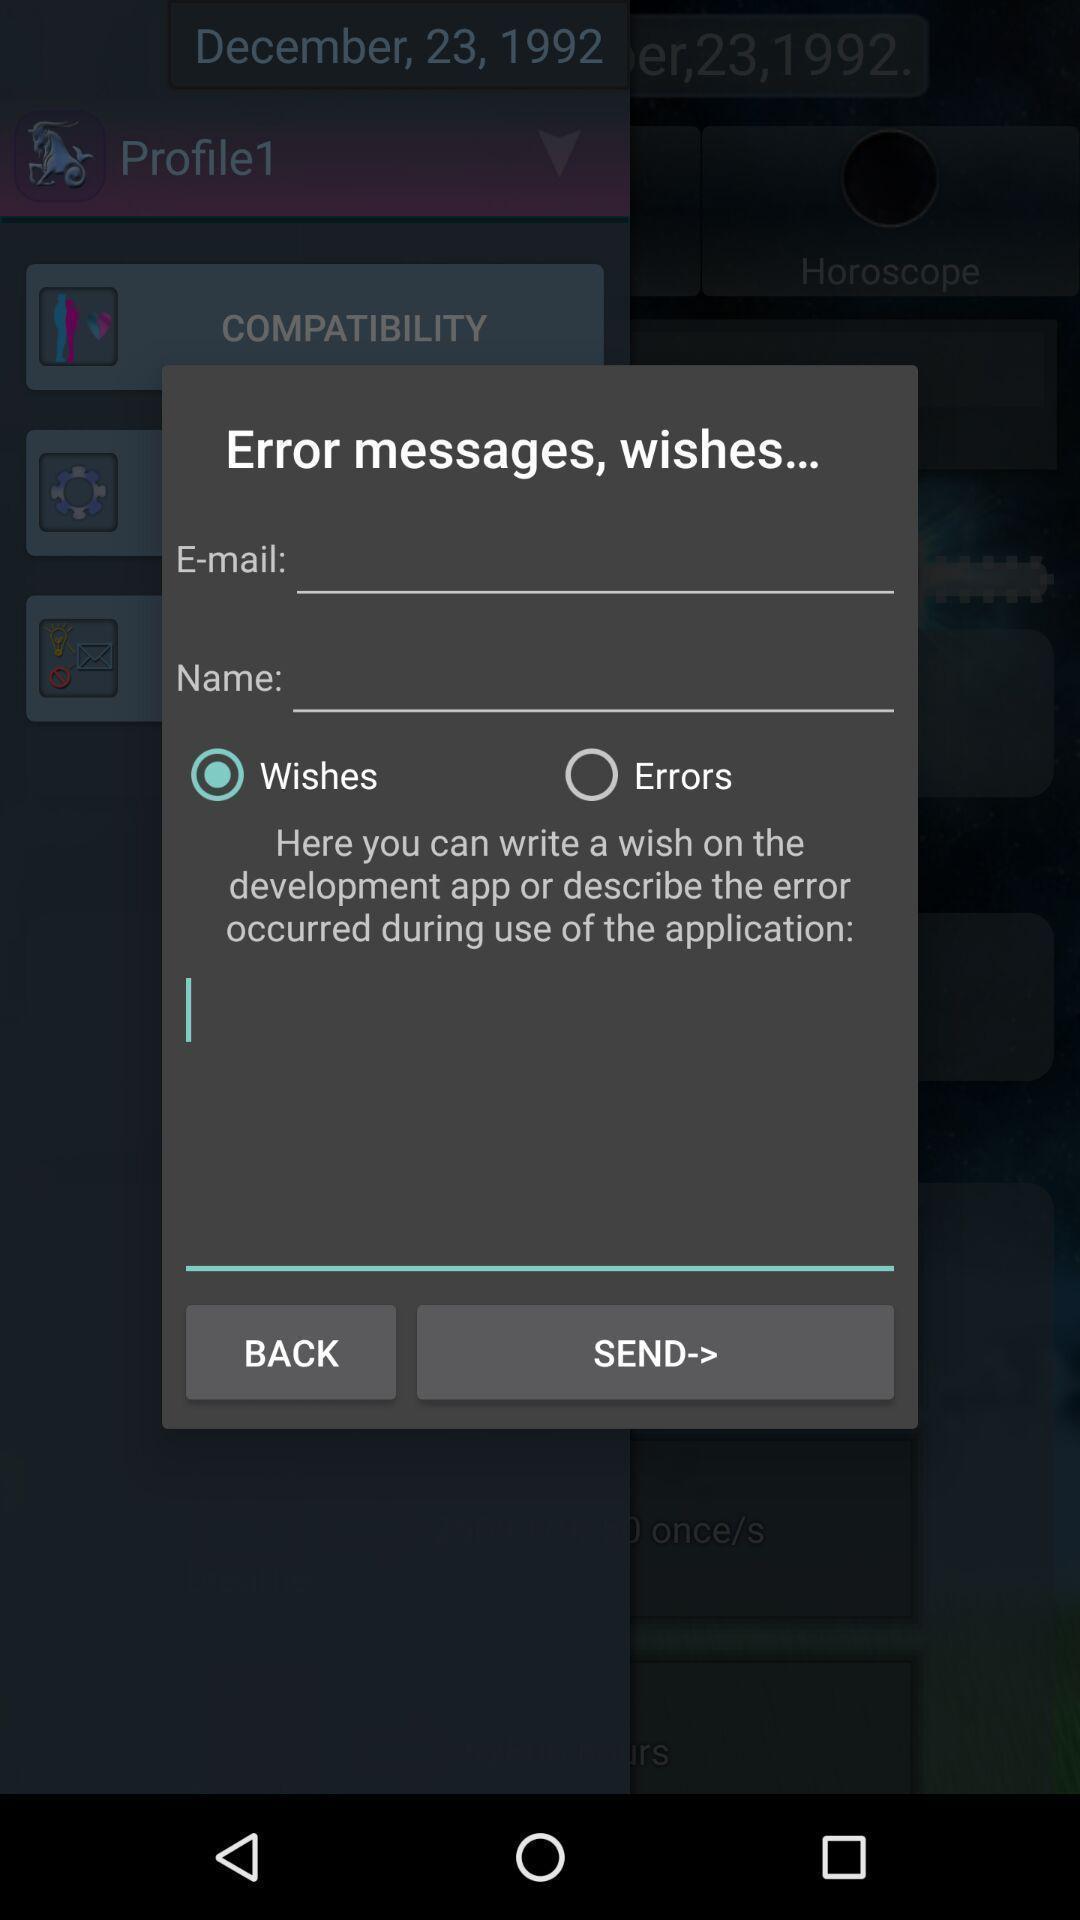Tell me what you see in this picture. Popup showing options for error messages. 